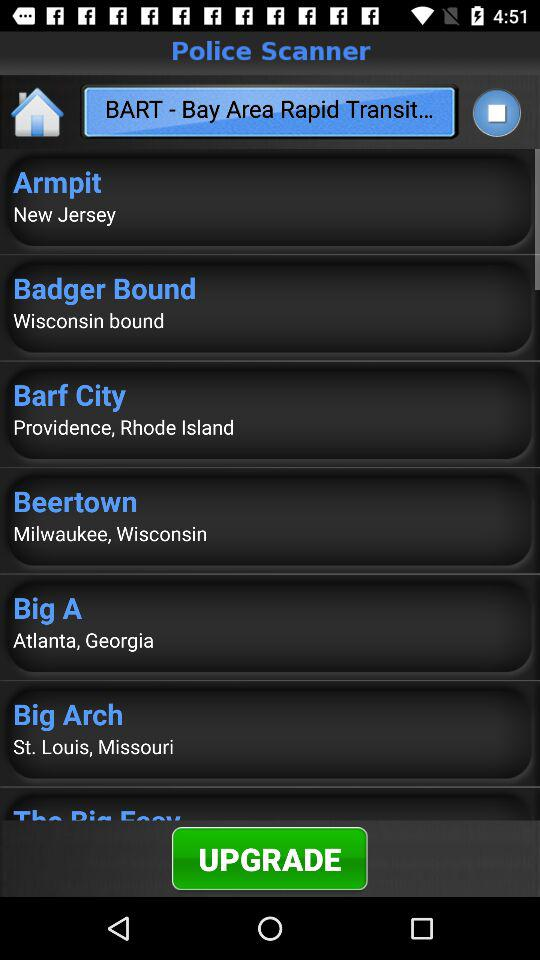What is the full form of BART? The full form of BART is "Bay Area Rapid Transit...". 